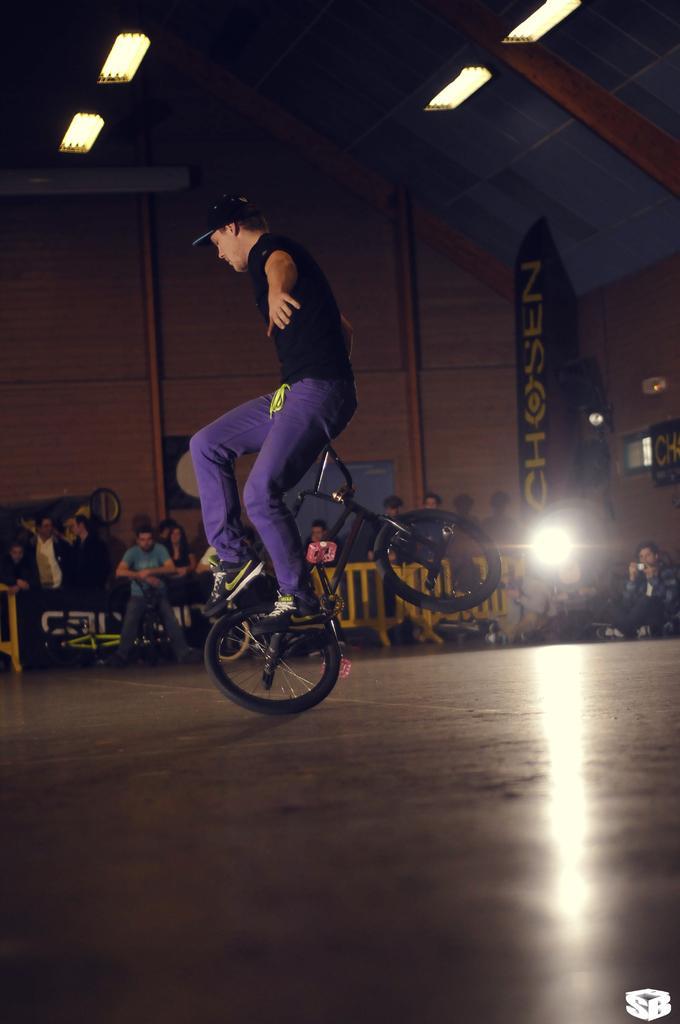Please provide a concise description of this image. In this image there are people, lights, railing, banners, floor, bicycle and objects. Among them one person is sitting on the bicycle handle.   